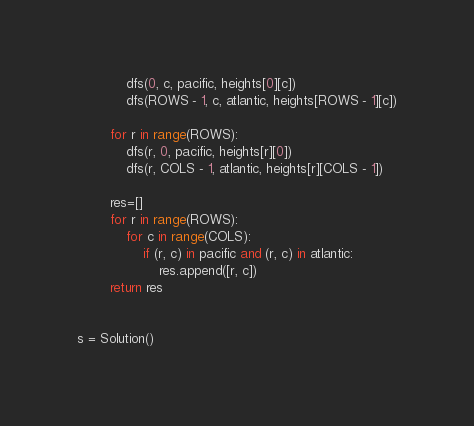Convert code to text. <code><loc_0><loc_0><loc_500><loc_500><_Python_>            dfs(0, c, pacific, heights[0][c])
            dfs(ROWS - 1, c, atlantic, heights[ROWS - 1][c])

        for r in range(ROWS):
            dfs(r, 0, pacific, heights[r][0])
            dfs(r, COLS - 1, atlantic, heights[r][COLS - 1])

        res=[]
        for r in range(ROWS):
            for c in range(COLS):
                if (r, c) in pacific and (r, c) in atlantic:
                    res.append([r, c])
        return res


s = Solution()</code> 